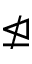Convert formula to latex. <formula><loc_0><loc_0><loc_500><loc_500>\ntrianglelefteq</formula> 